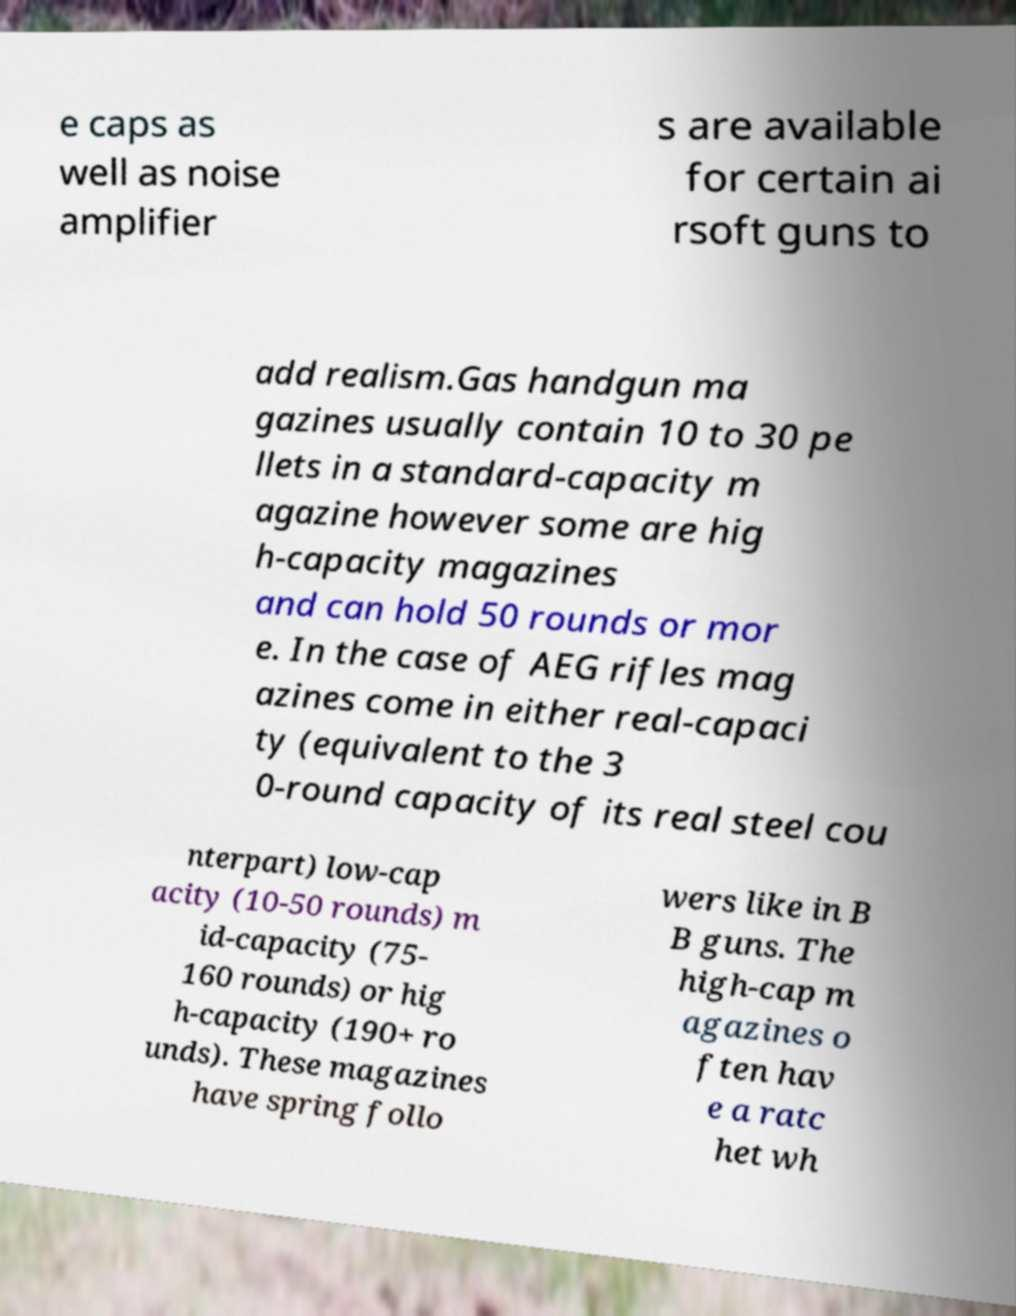Could you extract and type out the text from this image? e caps as well as noise amplifier s are available for certain ai rsoft guns to add realism.Gas handgun ma gazines usually contain 10 to 30 pe llets in a standard-capacity m agazine however some are hig h-capacity magazines and can hold 50 rounds or mor e. In the case of AEG rifles mag azines come in either real-capaci ty (equivalent to the 3 0-round capacity of its real steel cou nterpart) low-cap acity (10-50 rounds) m id-capacity (75- 160 rounds) or hig h-capacity (190+ ro unds). These magazines have spring follo wers like in B B guns. The high-cap m agazines o ften hav e a ratc het wh 